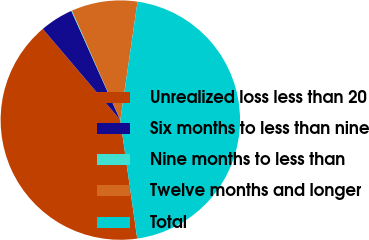<chart> <loc_0><loc_0><loc_500><loc_500><pie_chart><fcel>Unrealized loss less than 20<fcel>Six months to less than nine<fcel>Nine months to less than<fcel>Twelve months and longer<fcel>Total<nl><fcel>41.04%<fcel>4.5%<fcel>0.1%<fcel>8.91%<fcel>45.45%<nl></chart> 